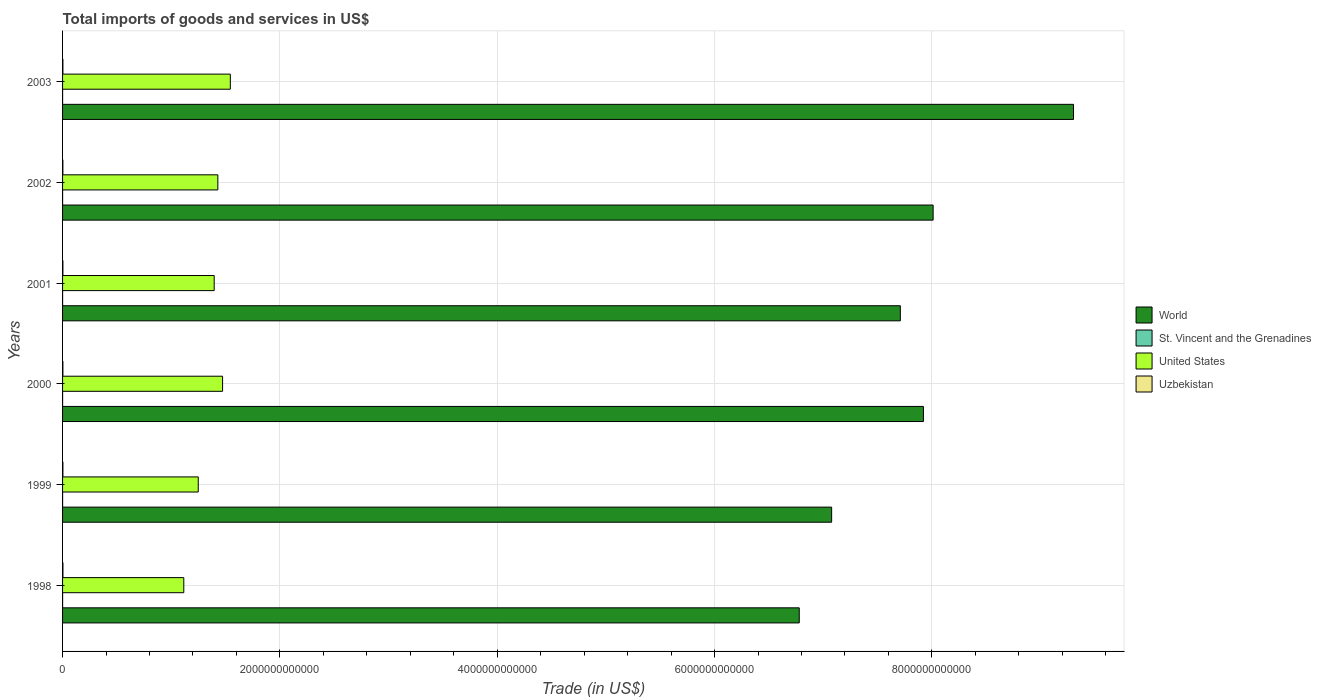How many groups of bars are there?
Your answer should be compact. 6. Are the number of bars per tick equal to the number of legend labels?
Your response must be concise. Yes. Are the number of bars on each tick of the Y-axis equal?
Provide a short and direct response. Yes. How many bars are there on the 5th tick from the bottom?
Offer a very short reply. 4. What is the total imports of goods and services in United States in 2000?
Make the answer very short. 1.47e+12. Across all years, what is the maximum total imports of goods and services in St. Vincent and the Grenadines?
Give a very brief answer. 2.49e+08. Across all years, what is the minimum total imports of goods and services in St. Vincent and the Grenadines?
Provide a succinct answer. 2.00e+08. In which year was the total imports of goods and services in Uzbekistan minimum?
Provide a short and direct response. 2002. What is the total total imports of goods and services in United States in the graph?
Provide a succinct answer. 8.21e+12. What is the difference between the total imports of goods and services in St. Vincent and the Grenadines in 2000 and that in 2002?
Offer a terse response. -1.43e+07. What is the difference between the total imports of goods and services in St. Vincent and the Grenadines in 2000 and the total imports of goods and services in World in 2001?
Your answer should be compact. -7.71e+12. What is the average total imports of goods and services in World per year?
Provide a short and direct response. 7.80e+12. In the year 2002, what is the difference between the total imports of goods and services in Uzbekistan and total imports of goods and services in World?
Give a very brief answer. -8.01e+12. What is the ratio of the total imports of goods and services in St. Vincent and the Grenadines in 1999 to that in 2001?
Offer a very short reply. 1.15. Is the total imports of goods and services in United States in 1998 less than that in 2001?
Offer a terse response. Yes. What is the difference between the highest and the second highest total imports of goods and services in St. Vincent and the Grenadines?
Offer a terse response. 7.62e+06. What is the difference between the highest and the lowest total imports of goods and services in United States?
Give a very brief answer. 4.28e+11. In how many years, is the total imports of goods and services in United States greater than the average total imports of goods and services in United States taken over all years?
Make the answer very short. 4. Is the sum of the total imports of goods and services in St. Vincent and the Grenadines in 1999 and 2003 greater than the maximum total imports of goods and services in United States across all years?
Your answer should be very brief. No. Is it the case that in every year, the sum of the total imports of goods and services in Uzbekistan and total imports of goods and services in World is greater than the sum of total imports of goods and services in United States and total imports of goods and services in St. Vincent and the Grenadines?
Provide a succinct answer. No. What does the 1st bar from the top in 2002 represents?
Your answer should be very brief. Uzbekistan. Is it the case that in every year, the sum of the total imports of goods and services in St. Vincent and the Grenadines and total imports of goods and services in Uzbekistan is greater than the total imports of goods and services in World?
Make the answer very short. No. How many years are there in the graph?
Provide a short and direct response. 6. What is the difference between two consecutive major ticks on the X-axis?
Offer a very short reply. 2.00e+12. What is the title of the graph?
Your response must be concise. Total imports of goods and services in US$. What is the label or title of the X-axis?
Ensure brevity in your answer.  Trade (in US$). What is the label or title of the Y-axis?
Provide a short and direct response. Years. What is the Trade (in US$) in World in 1998?
Keep it short and to the point. 6.78e+12. What is the Trade (in US$) of St. Vincent and the Grenadines in 1998?
Provide a short and direct response. 2.49e+08. What is the Trade (in US$) in United States in 1998?
Offer a very short reply. 1.12e+12. What is the Trade (in US$) in Uzbekistan in 1998?
Provide a succinct answer. 3.42e+09. What is the Trade (in US$) of World in 1999?
Your answer should be very brief. 7.08e+12. What is the Trade (in US$) in St. Vincent and the Grenadines in 1999?
Offer a very short reply. 2.40e+08. What is the Trade (in US$) in United States in 1999?
Give a very brief answer. 1.25e+12. What is the Trade (in US$) of Uzbekistan in 1999?
Your response must be concise. 3.14e+09. What is the Trade (in US$) in World in 2000?
Your response must be concise. 7.92e+12. What is the Trade (in US$) of St. Vincent and the Grenadines in 2000?
Your response must be concise. 2.00e+08. What is the Trade (in US$) in United States in 2000?
Your response must be concise. 1.47e+12. What is the Trade (in US$) in Uzbekistan in 2000?
Give a very brief answer. 2.96e+09. What is the Trade (in US$) of World in 2001?
Your response must be concise. 7.71e+12. What is the Trade (in US$) in St. Vincent and the Grenadines in 2001?
Provide a succinct answer. 2.09e+08. What is the Trade (in US$) in United States in 2001?
Provide a short and direct response. 1.40e+12. What is the Trade (in US$) of Uzbekistan in 2001?
Make the answer very short. 3.15e+09. What is the Trade (in US$) in World in 2002?
Make the answer very short. 8.01e+12. What is the Trade (in US$) of St. Vincent and the Grenadines in 2002?
Provide a short and direct response. 2.15e+08. What is the Trade (in US$) of United States in 2002?
Ensure brevity in your answer.  1.43e+12. What is the Trade (in US$) in Uzbekistan in 2002?
Your response must be concise. 2.84e+09. What is the Trade (in US$) in World in 2003?
Offer a very short reply. 9.30e+12. What is the Trade (in US$) in St. Vincent and the Grenadines in 2003?
Your answer should be very brief. 2.41e+08. What is the Trade (in US$) in United States in 2003?
Offer a terse response. 1.54e+12. What is the Trade (in US$) in Uzbekistan in 2003?
Give a very brief answer. 3.10e+09. Across all years, what is the maximum Trade (in US$) of World?
Keep it short and to the point. 9.30e+12. Across all years, what is the maximum Trade (in US$) of St. Vincent and the Grenadines?
Your answer should be very brief. 2.49e+08. Across all years, what is the maximum Trade (in US$) in United States?
Provide a short and direct response. 1.54e+12. Across all years, what is the maximum Trade (in US$) of Uzbekistan?
Your answer should be compact. 3.42e+09. Across all years, what is the minimum Trade (in US$) in World?
Keep it short and to the point. 6.78e+12. Across all years, what is the minimum Trade (in US$) of St. Vincent and the Grenadines?
Provide a succinct answer. 2.00e+08. Across all years, what is the minimum Trade (in US$) of United States?
Make the answer very short. 1.12e+12. Across all years, what is the minimum Trade (in US$) of Uzbekistan?
Ensure brevity in your answer.  2.84e+09. What is the total Trade (in US$) in World in the graph?
Ensure brevity in your answer.  4.68e+13. What is the total Trade (in US$) of St. Vincent and the Grenadines in the graph?
Make the answer very short. 1.36e+09. What is the total Trade (in US$) of United States in the graph?
Give a very brief answer. 8.21e+12. What is the total Trade (in US$) of Uzbekistan in the graph?
Offer a terse response. 1.86e+1. What is the difference between the Trade (in US$) in World in 1998 and that in 1999?
Keep it short and to the point. -2.98e+11. What is the difference between the Trade (in US$) of St. Vincent and the Grenadines in 1998 and that in 1999?
Keep it short and to the point. 9.04e+06. What is the difference between the Trade (in US$) in United States in 1998 and that in 1999?
Your answer should be compact. -1.33e+11. What is the difference between the Trade (in US$) of Uzbekistan in 1998 and that in 1999?
Offer a very short reply. 2.73e+08. What is the difference between the Trade (in US$) in World in 1998 and that in 2000?
Your answer should be very brief. -1.14e+12. What is the difference between the Trade (in US$) of St. Vincent and the Grenadines in 1998 and that in 2000?
Keep it short and to the point. 4.85e+07. What is the difference between the Trade (in US$) of United States in 1998 and that in 2000?
Provide a succinct answer. -3.57e+11. What is the difference between the Trade (in US$) of Uzbekistan in 1998 and that in 2000?
Your answer should be very brief. 4.55e+08. What is the difference between the Trade (in US$) of World in 1998 and that in 2001?
Your answer should be compact. -9.30e+11. What is the difference between the Trade (in US$) in St. Vincent and the Grenadines in 1998 and that in 2001?
Offer a very short reply. 3.96e+07. What is the difference between the Trade (in US$) of United States in 1998 and that in 2001?
Your answer should be compact. -2.80e+11. What is the difference between the Trade (in US$) of Uzbekistan in 1998 and that in 2001?
Offer a terse response. 2.65e+08. What is the difference between the Trade (in US$) in World in 1998 and that in 2002?
Make the answer very short. -1.23e+12. What is the difference between the Trade (in US$) in St. Vincent and the Grenadines in 1998 and that in 2002?
Provide a short and direct response. 3.42e+07. What is the difference between the Trade (in US$) of United States in 1998 and that in 2002?
Offer a terse response. -3.13e+11. What is the difference between the Trade (in US$) of Uzbekistan in 1998 and that in 2002?
Offer a terse response. 5.74e+08. What is the difference between the Trade (in US$) in World in 1998 and that in 2003?
Your answer should be very brief. -2.52e+12. What is the difference between the Trade (in US$) in St. Vincent and the Grenadines in 1998 and that in 2003?
Your response must be concise. 7.62e+06. What is the difference between the Trade (in US$) in United States in 1998 and that in 2003?
Ensure brevity in your answer.  -4.28e+11. What is the difference between the Trade (in US$) in Uzbekistan in 1998 and that in 2003?
Keep it short and to the point. 3.20e+08. What is the difference between the Trade (in US$) in World in 1999 and that in 2000?
Offer a terse response. -8.45e+11. What is the difference between the Trade (in US$) of St. Vincent and the Grenadines in 1999 and that in 2000?
Offer a very short reply. 3.95e+07. What is the difference between the Trade (in US$) of United States in 1999 and that in 2000?
Offer a very short reply. -2.24e+11. What is the difference between the Trade (in US$) of Uzbekistan in 1999 and that in 2000?
Your answer should be very brief. 1.82e+08. What is the difference between the Trade (in US$) in World in 1999 and that in 2001?
Your answer should be very brief. -6.32e+11. What is the difference between the Trade (in US$) of St. Vincent and the Grenadines in 1999 and that in 2001?
Keep it short and to the point. 3.05e+07. What is the difference between the Trade (in US$) of United States in 1999 and that in 2001?
Keep it short and to the point. -1.47e+11. What is the difference between the Trade (in US$) in Uzbekistan in 1999 and that in 2001?
Give a very brief answer. -8.00e+06. What is the difference between the Trade (in US$) in World in 1999 and that in 2002?
Keep it short and to the point. -9.34e+11. What is the difference between the Trade (in US$) in St. Vincent and the Grenadines in 1999 and that in 2002?
Your answer should be compact. 2.52e+07. What is the difference between the Trade (in US$) of United States in 1999 and that in 2002?
Your answer should be compact. -1.80e+11. What is the difference between the Trade (in US$) in Uzbekistan in 1999 and that in 2002?
Ensure brevity in your answer.  3.01e+08. What is the difference between the Trade (in US$) of World in 1999 and that in 2003?
Your answer should be very brief. -2.23e+12. What is the difference between the Trade (in US$) of St. Vincent and the Grenadines in 1999 and that in 2003?
Give a very brief answer. -1.42e+06. What is the difference between the Trade (in US$) in United States in 1999 and that in 2003?
Your response must be concise. -2.95e+11. What is the difference between the Trade (in US$) of Uzbekistan in 1999 and that in 2003?
Keep it short and to the point. 4.70e+07. What is the difference between the Trade (in US$) of World in 2000 and that in 2001?
Your response must be concise. 2.13e+11. What is the difference between the Trade (in US$) in St. Vincent and the Grenadines in 2000 and that in 2001?
Ensure brevity in your answer.  -8.99e+06. What is the difference between the Trade (in US$) of United States in 2000 and that in 2001?
Make the answer very short. 7.72e+1. What is the difference between the Trade (in US$) in Uzbekistan in 2000 and that in 2001?
Your answer should be very brief. -1.90e+08. What is the difference between the Trade (in US$) in World in 2000 and that in 2002?
Give a very brief answer. -8.91e+1. What is the difference between the Trade (in US$) of St. Vincent and the Grenadines in 2000 and that in 2002?
Your answer should be very brief. -1.43e+07. What is the difference between the Trade (in US$) of United States in 2000 and that in 2002?
Offer a terse response. 4.37e+1. What is the difference between the Trade (in US$) in Uzbekistan in 2000 and that in 2002?
Your answer should be very brief. 1.19e+08. What is the difference between the Trade (in US$) in World in 2000 and that in 2003?
Give a very brief answer. -1.38e+12. What is the difference between the Trade (in US$) of St. Vincent and the Grenadines in 2000 and that in 2003?
Make the answer very short. -4.09e+07. What is the difference between the Trade (in US$) in United States in 2000 and that in 2003?
Ensure brevity in your answer.  -7.13e+1. What is the difference between the Trade (in US$) in Uzbekistan in 2000 and that in 2003?
Give a very brief answer. -1.35e+08. What is the difference between the Trade (in US$) in World in 2001 and that in 2002?
Make the answer very short. -3.02e+11. What is the difference between the Trade (in US$) of St. Vincent and the Grenadines in 2001 and that in 2002?
Ensure brevity in your answer.  -5.36e+06. What is the difference between the Trade (in US$) of United States in 2001 and that in 2002?
Keep it short and to the point. -3.36e+1. What is the difference between the Trade (in US$) of Uzbekistan in 2001 and that in 2002?
Your answer should be very brief. 3.09e+08. What is the difference between the Trade (in US$) of World in 2001 and that in 2003?
Make the answer very short. -1.59e+12. What is the difference between the Trade (in US$) in St. Vincent and the Grenadines in 2001 and that in 2003?
Give a very brief answer. -3.19e+07. What is the difference between the Trade (in US$) in United States in 2001 and that in 2003?
Offer a terse response. -1.49e+11. What is the difference between the Trade (in US$) of Uzbekistan in 2001 and that in 2003?
Give a very brief answer. 5.50e+07. What is the difference between the Trade (in US$) of World in 2002 and that in 2003?
Provide a succinct answer. -1.29e+12. What is the difference between the Trade (in US$) of St. Vincent and the Grenadines in 2002 and that in 2003?
Offer a terse response. -2.66e+07. What is the difference between the Trade (in US$) of United States in 2002 and that in 2003?
Ensure brevity in your answer.  -1.15e+11. What is the difference between the Trade (in US$) of Uzbekistan in 2002 and that in 2003?
Give a very brief answer. -2.54e+08. What is the difference between the Trade (in US$) of World in 1998 and the Trade (in US$) of St. Vincent and the Grenadines in 1999?
Make the answer very short. 6.78e+12. What is the difference between the Trade (in US$) of World in 1998 and the Trade (in US$) of United States in 1999?
Provide a succinct answer. 5.53e+12. What is the difference between the Trade (in US$) of World in 1998 and the Trade (in US$) of Uzbekistan in 1999?
Keep it short and to the point. 6.78e+12. What is the difference between the Trade (in US$) in St. Vincent and the Grenadines in 1998 and the Trade (in US$) in United States in 1999?
Offer a very short reply. -1.25e+12. What is the difference between the Trade (in US$) in St. Vincent and the Grenadines in 1998 and the Trade (in US$) in Uzbekistan in 1999?
Provide a succinct answer. -2.89e+09. What is the difference between the Trade (in US$) of United States in 1998 and the Trade (in US$) of Uzbekistan in 1999?
Your response must be concise. 1.11e+12. What is the difference between the Trade (in US$) of World in 1998 and the Trade (in US$) of St. Vincent and the Grenadines in 2000?
Give a very brief answer. 6.78e+12. What is the difference between the Trade (in US$) of World in 1998 and the Trade (in US$) of United States in 2000?
Provide a succinct answer. 5.31e+12. What is the difference between the Trade (in US$) of World in 1998 and the Trade (in US$) of Uzbekistan in 2000?
Provide a short and direct response. 6.78e+12. What is the difference between the Trade (in US$) in St. Vincent and the Grenadines in 1998 and the Trade (in US$) in United States in 2000?
Provide a succinct answer. -1.47e+12. What is the difference between the Trade (in US$) of St. Vincent and the Grenadines in 1998 and the Trade (in US$) of Uzbekistan in 2000?
Provide a short and direct response. -2.71e+09. What is the difference between the Trade (in US$) of United States in 1998 and the Trade (in US$) of Uzbekistan in 2000?
Provide a short and direct response. 1.11e+12. What is the difference between the Trade (in US$) of World in 1998 and the Trade (in US$) of St. Vincent and the Grenadines in 2001?
Make the answer very short. 6.78e+12. What is the difference between the Trade (in US$) in World in 1998 and the Trade (in US$) in United States in 2001?
Offer a very short reply. 5.38e+12. What is the difference between the Trade (in US$) in World in 1998 and the Trade (in US$) in Uzbekistan in 2001?
Your answer should be compact. 6.78e+12. What is the difference between the Trade (in US$) of St. Vincent and the Grenadines in 1998 and the Trade (in US$) of United States in 2001?
Give a very brief answer. -1.40e+12. What is the difference between the Trade (in US$) of St. Vincent and the Grenadines in 1998 and the Trade (in US$) of Uzbekistan in 2001?
Make the answer very short. -2.90e+09. What is the difference between the Trade (in US$) in United States in 1998 and the Trade (in US$) in Uzbekistan in 2001?
Make the answer very short. 1.11e+12. What is the difference between the Trade (in US$) in World in 1998 and the Trade (in US$) in St. Vincent and the Grenadines in 2002?
Provide a succinct answer. 6.78e+12. What is the difference between the Trade (in US$) in World in 1998 and the Trade (in US$) in United States in 2002?
Provide a short and direct response. 5.35e+12. What is the difference between the Trade (in US$) in World in 1998 and the Trade (in US$) in Uzbekistan in 2002?
Your answer should be very brief. 6.78e+12. What is the difference between the Trade (in US$) of St. Vincent and the Grenadines in 1998 and the Trade (in US$) of United States in 2002?
Keep it short and to the point. -1.43e+12. What is the difference between the Trade (in US$) of St. Vincent and the Grenadines in 1998 and the Trade (in US$) of Uzbekistan in 2002?
Provide a succinct answer. -2.59e+09. What is the difference between the Trade (in US$) in United States in 1998 and the Trade (in US$) in Uzbekistan in 2002?
Provide a succinct answer. 1.11e+12. What is the difference between the Trade (in US$) in World in 1998 and the Trade (in US$) in St. Vincent and the Grenadines in 2003?
Offer a terse response. 6.78e+12. What is the difference between the Trade (in US$) in World in 1998 and the Trade (in US$) in United States in 2003?
Ensure brevity in your answer.  5.24e+12. What is the difference between the Trade (in US$) in World in 1998 and the Trade (in US$) in Uzbekistan in 2003?
Your response must be concise. 6.78e+12. What is the difference between the Trade (in US$) of St. Vincent and the Grenadines in 1998 and the Trade (in US$) of United States in 2003?
Make the answer very short. -1.54e+12. What is the difference between the Trade (in US$) of St. Vincent and the Grenadines in 1998 and the Trade (in US$) of Uzbekistan in 2003?
Make the answer very short. -2.85e+09. What is the difference between the Trade (in US$) in United States in 1998 and the Trade (in US$) in Uzbekistan in 2003?
Ensure brevity in your answer.  1.11e+12. What is the difference between the Trade (in US$) of World in 1999 and the Trade (in US$) of St. Vincent and the Grenadines in 2000?
Your answer should be compact. 7.08e+12. What is the difference between the Trade (in US$) in World in 1999 and the Trade (in US$) in United States in 2000?
Keep it short and to the point. 5.61e+12. What is the difference between the Trade (in US$) of World in 1999 and the Trade (in US$) of Uzbekistan in 2000?
Offer a very short reply. 7.07e+12. What is the difference between the Trade (in US$) of St. Vincent and the Grenadines in 1999 and the Trade (in US$) of United States in 2000?
Offer a terse response. -1.47e+12. What is the difference between the Trade (in US$) in St. Vincent and the Grenadines in 1999 and the Trade (in US$) in Uzbekistan in 2000?
Give a very brief answer. -2.72e+09. What is the difference between the Trade (in US$) of United States in 1999 and the Trade (in US$) of Uzbekistan in 2000?
Provide a succinct answer. 1.25e+12. What is the difference between the Trade (in US$) in World in 1999 and the Trade (in US$) in St. Vincent and the Grenadines in 2001?
Offer a terse response. 7.08e+12. What is the difference between the Trade (in US$) in World in 1999 and the Trade (in US$) in United States in 2001?
Provide a succinct answer. 5.68e+12. What is the difference between the Trade (in US$) in World in 1999 and the Trade (in US$) in Uzbekistan in 2001?
Offer a very short reply. 7.07e+12. What is the difference between the Trade (in US$) of St. Vincent and the Grenadines in 1999 and the Trade (in US$) of United States in 2001?
Give a very brief answer. -1.40e+12. What is the difference between the Trade (in US$) of St. Vincent and the Grenadines in 1999 and the Trade (in US$) of Uzbekistan in 2001?
Your answer should be compact. -2.91e+09. What is the difference between the Trade (in US$) in United States in 1999 and the Trade (in US$) in Uzbekistan in 2001?
Ensure brevity in your answer.  1.25e+12. What is the difference between the Trade (in US$) in World in 1999 and the Trade (in US$) in St. Vincent and the Grenadines in 2002?
Offer a terse response. 7.08e+12. What is the difference between the Trade (in US$) in World in 1999 and the Trade (in US$) in United States in 2002?
Provide a succinct answer. 5.65e+12. What is the difference between the Trade (in US$) of World in 1999 and the Trade (in US$) of Uzbekistan in 2002?
Provide a succinct answer. 7.07e+12. What is the difference between the Trade (in US$) in St. Vincent and the Grenadines in 1999 and the Trade (in US$) in United States in 2002?
Provide a short and direct response. -1.43e+12. What is the difference between the Trade (in US$) in St. Vincent and the Grenadines in 1999 and the Trade (in US$) in Uzbekistan in 2002?
Provide a succinct answer. -2.60e+09. What is the difference between the Trade (in US$) in United States in 1999 and the Trade (in US$) in Uzbekistan in 2002?
Keep it short and to the point. 1.25e+12. What is the difference between the Trade (in US$) of World in 1999 and the Trade (in US$) of St. Vincent and the Grenadines in 2003?
Your response must be concise. 7.08e+12. What is the difference between the Trade (in US$) in World in 1999 and the Trade (in US$) in United States in 2003?
Offer a terse response. 5.53e+12. What is the difference between the Trade (in US$) in World in 1999 and the Trade (in US$) in Uzbekistan in 2003?
Your response must be concise. 7.07e+12. What is the difference between the Trade (in US$) of St. Vincent and the Grenadines in 1999 and the Trade (in US$) of United States in 2003?
Provide a short and direct response. -1.54e+12. What is the difference between the Trade (in US$) of St. Vincent and the Grenadines in 1999 and the Trade (in US$) of Uzbekistan in 2003?
Ensure brevity in your answer.  -2.86e+09. What is the difference between the Trade (in US$) of United States in 1999 and the Trade (in US$) of Uzbekistan in 2003?
Your answer should be compact. 1.25e+12. What is the difference between the Trade (in US$) of World in 2000 and the Trade (in US$) of St. Vincent and the Grenadines in 2001?
Give a very brief answer. 7.92e+12. What is the difference between the Trade (in US$) in World in 2000 and the Trade (in US$) in United States in 2001?
Make the answer very short. 6.53e+12. What is the difference between the Trade (in US$) of World in 2000 and the Trade (in US$) of Uzbekistan in 2001?
Your answer should be compact. 7.92e+12. What is the difference between the Trade (in US$) of St. Vincent and the Grenadines in 2000 and the Trade (in US$) of United States in 2001?
Your answer should be compact. -1.40e+12. What is the difference between the Trade (in US$) of St. Vincent and the Grenadines in 2000 and the Trade (in US$) of Uzbekistan in 2001?
Keep it short and to the point. -2.95e+09. What is the difference between the Trade (in US$) of United States in 2000 and the Trade (in US$) of Uzbekistan in 2001?
Give a very brief answer. 1.47e+12. What is the difference between the Trade (in US$) of World in 2000 and the Trade (in US$) of St. Vincent and the Grenadines in 2002?
Offer a very short reply. 7.92e+12. What is the difference between the Trade (in US$) in World in 2000 and the Trade (in US$) in United States in 2002?
Provide a short and direct response. 6.49e+12. What is the difference between the Trade (in US$) in World in 2000 and the Trade (in US$) in Uzbekistan in 2002?
Provide a short and direct response. 7.92e+12. What is the difference between the Trade (in US$) in St. Vincent and the Grenadines in 2000 and the Trade (in US$) in United States in 2002?
Keep it short and to the point. -1.43e+12. What is the difference between the Trade (in US$) in St. Vincent and the Grenadines in 2000 and the Trade (in US$) in Uzbekistan in 2002?
Give a very brief answer. -2.64e+09. What is the difference between the Trade (in US$) of United States in 2000 and the Trade (in US$) of Uzbekistan in 2002?
Your response must be concise. 1.47e+12. What is the difference between the Trade (in US$) of World in 2000 and the Trade (in US$) of St. Vincent and the Grenadines in 2003?
Your answer should be very brief. 7.92e+12. What is the difference between the Trade (in US$) in World in 2000 and the Trade (in US$) in United States in 2003?
Make the answer very short. 6.38e+12. What is the difference between the Trade (in US$) in World in 2000 and the Trade (in US$) in Uzbekistan in 2003?
Provide a short and direct response. 7.92e+12. What is the difference between the Trade (in US$) in St. Vincent and the Grenadines in 2000 and the Trade (in US$) in United States in 2003?
Offer a very short reply. -1.54e+12. What is the difference between the Trade (in US$) of St. Vincent and the Grenadines in 2000 and the Trade (in US$) of Uzbekistan in 2003?
Ensure brevity in your answer.  -2.90e+09. What is the difference between the Trade (in US$) in United States in 2000 and the Trade (in US$) in Uzbekistan in 2003?
Your response must be concise. 1.47e+12. What is the difference between the Trade (in US$) in World in 2001 and the Trade (in US$) in St. Vincent and the Grenadines in 2002?
Keep it short and to the point. 7.71e+12. What is the difference between the Trade (in US$) of World in 2001 and the Trade (in US$) of United States in 2002?
Provide a succinct answer. 6.28e+12. What is the difference between the Trade (in US$) of World in 2001 and the Trade (in US$) of Uzbekistan in 2002?
Ensure brevity in your answer.  7.71e+12. What is the difference between the Trade (in US$) in St. Vincent and the Grenadines in 2001 and the Trade (in US$) in United States in 2002?
Keep it short and to the point. -1.43e+12. What is the difference between the Trade (in US$) in St. Vincent and the Grenadines in 2001 and the Trade (in US$) in Uzbekistan in 2002?
Your answer should be very brief. -2.63e+09. What is the difference between the Trade (in US$) in United States in 2001 and the Trade (in US$) in Uzbekistan in 2002?
Keep it short and to the point. 1.39e+12. What is the difference between the Trade (in US$) of World in 2001 and the Trade (in US$) of St. Vincent and the Grenadines in 2003?
Offer a terse response. 7.71e+12. What is the difference between the Trade (in US$) of World in 2001 and the Trade (in US$) of United States in 2003?
Offer a terse response. 6.17e+12. What is the difference between the Trade (in US$) of World in 2001 and the Trade (in US$) of Uzbekistan in 2003?
Give a very brief answer. 7.71e+12. What is the difference between the Trade (in US$) of St. Vincent and the Grenadines in 2001 and the Trade (in US$) of United States in 2003?
Provide a short and direct response. -1.54e+12. What is the difference between the Trade (in US$) of St. Vincent and the Grenadines in 2001 and the Trade (in US$) of Uzbekistan in 2003?
Offer a very short reply. -2.89e+09. What is the difference between the Trade (in US$) in United States in 2001 and the Trade (in US$) in Uzbekistan in 2003?
Offer a terse response. 1.39e+12. What is the difference between the Trade (in US$) of World in 2002 and the Trade (in US$) of St. Vincent and the Grenadines in 2003?
Give a very brief answer. 8.01e+12. What is the difference between the Trade (in US$) of World in 2002 and the Trade (in US$) of United States in 2003?
Make the answer very short. 6.47e+12. What is the difference between the Trade (in US$) of World in 2002 and the Trade (in US$) of Uzbekistan in 2003?
Make the answer very short. 8.01e+12. What is the difference between the Trade (in US$) in St. Vincent and the Grenadines in 2002 and the Trade (in US$) in United States in 2003?
Keep it short and to the point. -1.54e+12. What is the difference between the Trade (in US$) in St. Vincent and the Grenadines in 2002 and the Trade (in US$) in Uzbekistan in 2003?
Your response must be concise. -2.88e+09. What is the difference between the Trade (in US$) of United States in 2002 and the Trade (in US$) of Uzbekistan in 2003?
Provide a short and direct response. 1.43e+12. What is the average Trade (in US$) of World per year?
Provide a short and direct response. 7.80e+12. What is the average Trade (in US$) in St. Vincent and the Grenadines per year?
Your answer should be very brief. 2.26e+08. What is the average Trade (in US$) of United States per year?
Make the answer very short. 1.37e+12. What is the average Trade (in US$) in Uzbekistan per year?
Offer a very short reply. 3.10e+09. In the year 1998, what is the difference between the Trade (in US$) in World and Trade (in US$) in St. Vincent and the Grenadines?
Give a very brief answer. 6.78e+12. In the year 1998, what is the difference between the Trade (in US$) of World and Trade (in US$) of United States?
Offer a terse response. 5.66e+12. In the year 1998, what is the difference between the Trade (in US$) in World and Trade (in US$) in Uzbekistan?
Offer a terse response. 6.78e+12. In the year 1998, what is the difference between the Trade (in US$) in St. Vincent and the Grenadines and Trade (in US$) in United States?
Your answer should be compact. -1.12e+12. In the year 1998, what is the difference between the Trade (in US$) of St. Vincent and the Grenadines and Trade (in US$) of Uzbekistan?
Your response must be concise. -3.17e+09. In the year 1998, what is the difference between the Trade (in US$) of United States and Trade (in US$) of Uzbekistan?
Your response must be concise. 1.11e+12. In the year 1999, what is the difference between the Trade (in US$) in World and Trade (in US$) in St. Vincent and the Grenadines?
Offer a terse response. 7.08e+12. In the year 1999, what is the difference between the Trade (in US$) of World and Trade (in US$) of United States?
Your answer should be compact. 5.83e+12. In the year 1999, what is the difference between the Trade (in US$) in World and Trade (in US$) in Uzbekistan?
Provide a succinct answer. 7.07e+12. In the year 1999, what is the difference between the Trade (in US$) in St. Vincent and the Grenadines and Trade (in US$) in United States?
Offer a terse response. -1.25e+12. In the year 1999, what is the difference between the Trade (in US$) of St. Vincent and the Grenadines and Trade (in US$) of Uzbekistan?
Keep it short and to the point. -2.90e+09. In the year 1999, what is the difference between the Trade (in US$) of United States and Trade (in US$) of Uzbekistan?
Offer a very short reply. 1.25e+12. In the year 2000, what is the difference between the Trade (in US$) in World and Trade (in US$) in St. Vincent and the Grenadines?
Your answer should be very brief. 7.92e+12. In the year 2000, what is the difference between the Trade (in US$) in World and Trade (in US$) in United States?
Offer a very short reply. 6.45e+12. In the year 2000, what is the difference between the Trade (in US$) of World and Trade (in US$) of Uzbekistan?
Give a very brief answer. 7.92e+12. In the year 2000, what is the difference between the Trade (in US$) of St. Vincent and the Grenadines and Trade (in US$) of United States?
Provide a succinct answer. -1.47e+12. In the year 2000, what is the difference between the Trade (in US$) in St. Vincent and the Grenadines and Trade (in US$) in Uzbekistan?
Give a very brief answer. -2.76e+09. In the year 2000, what is the difference between the Trade (in US$) of United States and Trade (in US$) of Uzbekistan?
Give a very brief answer. 1.47e+12. In the year 2001, what is the difference between the Trade (in US$) in World and Trade (in US$) in St. Vincent and the Grenadines?
Your answer should be very brief. 7.71e+12. In the year 2001, what is the difference between the Trade (in US$) in World and Trade (in US$) in United States?
Keep it short and to the point. 6.31e+12. In the year 2001, what is the difference between the Trade (in US$) of World and Trade (in US$) of Uzbekistan?
Keep it short and to the point. 7.71e+12. In the year 2001, what is the difference between the Trade (in US$) of St. Vincent and the Grenadines and Trade (in US$) of United States?
Give a very brief answer. -1.40e+12. In the year 2001, what is the difference between the Trade (in US$) of St. Vincent and the Grenadines and Trade (in US$) of Uzbekistan?
Provide a short and direct response. -2.94e+09. In the year 2001, what is the difference between the Trade (in US$) in United States and Trade (in US$) in Uzbekistan?
Your answer should be compact. 1.39e+12. In the year 2002, what is the difference between the Trade (in US$) of World and Trade (in US$) of St. Vincent and the Grenadines?
Your answer should be compact. 8.01e+12. In the year 2002, what is the difference between the Trade (in US$) of World and Trade (in US$) of United States?
Your response must be concise. 6.58e+12. In the year 2002, what is the difference between the Trade (in US$) of World and Trade (in US$) of Uzbekistan?
Provide a short and direct response. 8.01e+12. In the year 2002, what is the difference between the Trade (in US$) of St. Vincent and the Grenadines and Trade (in US$) of United States?
Your answer should be very brief. -1.43e+12. In the year 2002, what is the difference between the Trade (in US$) in St. Vincent and the Grenadines and Trade (in US$) in Uzbekistan?
Provide a short and direct response. -2.63e+09. In the year 2002, what is the difference between the Trade (in US$) of United States and Trade (in US$) of Uzbekistan?
Offer a terse response. 1.43e+12. In the year 2003, what is the difference between the Trade (in US$) in World and Trade (in US$) in St. Vincent and the Grenadines?
Offer a very short reply. 9.30e+12. In the year 2003, what is the difference between the Trade (in US$) in World and Trade (in US$) in United States?
Make the answer very short. 7.76e+12. In the year 2003, what is the difference between the Trade (in US$) of World and Trade (in US$) of Uzbekistan?
Ensure brevity in your answer.  9.30e+12. In the year 2003, what is the difference between the Trade (in US$) of St. Vincent and the Grenadines and Trade (in US$) of United States?
Ensure brevity in your answer.  -1.54e+12. In the year 2003, what is the difference between the Trade (in US$) in St. Vincent and the Grenadines and Trade (in US$) in Uzbekistan?
Provide a succinct answer. -2.86e+09. In the year 2003, what is the difference between the Trade (in US$) of United States and Trade (in US$) of Uzbekistan?
Provide a short and direct response. 1.54e+12. What is the ratio of the Trade (in US$) of World in 1998 to that in 1999?
Your answer should be compact. 0.96. What is the ratio of the Trade (in US$) of St. Vincent and the Grenadines in 1998 to that in 1999?
Your answer should be compact. 1.04. What is the ratio of the Trade (in US$) in United States in 1998 to that in 1999?
Keep it short and to the point. 0.89. What is the ratio of the Trade (in US$) in Uzbekistan in 1998 to that in 1999?
Your answer should be very brief. 1.09. What is the ratio of the Trade (in US$) in World in 1998 to that in 2000?
Give a very brief answer. 0.86. What is the ratio of the Trade (in US$) of St. Vincent and the Grenadines in 1998 to that in 2000?
Keep it short and to the point. 1.24. What is the ratio of the Trade (in US$) of United States in 1998 to that in 2000?
Make the answer very short. 0.76. What is the ratio of the Trade (in US$) of Uzbekistan in 1998 to that in 2000?
Ensure brevity in your answer.  1.15. What is the ratio of the Trade (in US$) of World in 1998 to that in 2001?
Offer a terse response. 0.88. What is the ratio of the Trade (in US$) of St. Vincent and the Grenadines in 1998 to that in 2001?
Provide a succinct answer. 1.19. What is the ratio of the Trade (in US$) of United States in 1998 to that in 2001?
Provide a short and direct response. 0.8. What is the ratio of the Trade (in US$) of Uzbekistan in 1998 to that in 2001?
Provide a short and direct response. 1.08. What is the ratio of the Trade (in US$) of World in 1998 to that in 2002?
Offer a terse response. 0.85. What is the ratio of the Trade (in US$) of St. Vincent and the Grenadines in 1998 to that in 2002?
Make the answer very short. 1.16. What is the ratio of the Trade (in US$) of United States in 1998 to that in 2002?
Provide a short and direct response. 0.78. What is the ratio of the Trade (in US$) in Uzbekistan in 1998 to that in 2002?
Your answer should be very brief. 1.2. What is the ratio of the Trade (in US$) in World in 1998 to that in 2003?
Provide a short and direct response. 0.73. What is the ratio of the Trade (in US$) in St. Vincent and the Grenadines in 1998 to that in 2003?
Your response must be concise. 1.03. What is the ratio of the Trade (in US$) of United States in 1998 to that in 2003?
Your response must be concise. 0.72. What is the ratio of the Trade (in US$) of Uzbekistan in 1998 to that in 2003?
Your response must be concise. 1.1. What is the ratio of the Trade (in US$) in World in 1999 to that in 2000?
Make the answer very short. 0.89. What is the ratio of the Trade (in US$) in St. Vincent and the Grenadines in 1999 to that in 2000?
Your answer should be very brief. 1.2. What is the ratio of the Trade (in US$) of United States in 1999 to that in 2000?
Your response must be concise. 0.85. What is the ratio of the Trade (in US$) of Uzbekistan in 1999 to that in 2000?
Provide a succinct answer. 1.06. What is the ratio of the Trade (in US$) in World in 1999 to that in 2001?
Provide a succinct answer. 0.92. What is the ratio of the Trade (in US$) of St. Vincent and the Grenadines in 1999 to that in 2001?
Your answer should be very brief. 1.15. What is the ratio of the Trade (in US$) in United States in 1999 to that in 2001?
Your response must be concise. 0.89. What is the ratio of the Trade (in US$) in World in 1999 to that in 2002?
Ensure brevity in your answer.  0.88. What is the ratio of the Trade (in US$) in St. Vincent and the Grenadines in 1999 to that in 2002?
Provide a succinct answer. 1.12. What is the ratio of the Trade (in US$) in United States in 1999 to that in 2002?
Ensure brevity in your answer.  0.87. What is the ratio of the Trade (in US$) of Uzbekistan in 1999 to that in 2002?
Ensure brevity in your answer.  1.11. What is the ratio of the Trade (in US$) of World in 1999 to that in 2003?
Keep it short and to the point. 0.76. What is the ratio of the Trade (in US$) in St. Vincent and the Grenadines in 1999 to that in 2003?
Make the answer very short. 0.99. What is the ratio of the Trade (in US$) in United States in 1999 to that in 2003?
Provide a short and direct response. 0.81. What is the ratio of the Trade (in US$) of Uzbekistan in 1999 to that in 2003?
Your answer should be compact. 1.02. What is the ratio of the Trade (in US$) of World in 2000 to that in 2001?
Provide a short and direct response. 1.03. What is the ratio of the Trade (in US$) of St. Vincent and the Grenadines in 2000 to that in 2001?
Give a very brief answer. 0.96. What is the ratio of the Trade (in US$) in United States in 2000 to that in 2001?
Keep it short and to the point. 1.06. What is the ratio of the Trade (in US$) in Uzbekistan in 2000 to that in 2001?
Give a very brief answer. 0.94. What is the ratio of the Trade (in US$) in World in 2000 to that in 2002?
Offer a very short reply. 0.99. What is the ratio of the Trade (in US$) in St. Vincent and the Grenadines in 2000 to that in 2002?
Offer a terse response. 0.93. What is the ratio of the Trade (in US$) of United States in 2000 to that in 2002?
Your answer should be compact. 1.03. What is the ratio of the Trade (in US$) in Uzbekistan in 2000 to that in 2002?
Your response must be concise. 1.04. What is the ratio of the Trade (in US$) in World in 2000 to that in 2003?
Your answer should be very brief. 0.85. What is the ratio of the Trade (in US$) in St. Vincent and the Grenadines in 2000 to that in 2003?
Provide a succinct answer. 0.83. What is the ratio of the Trade (in US$) in United States in 2000 to that in 2003?
Provide a succinct answer. 0.95. What is the ratio of the Trade (in US$) of Uzbekistan in 2000 to that in 2003?
Make the answer very short. 0.96. What is the ratio of the Trade (in US$) of World in 2001 to that in 2002?
Provide a succinct answer. 0.96. What is the ratio of the Trade (in US$) of United States in 2001 to that in 2002?
Your answer should be compact. 0.98. What is the ratio of the Trade (in US$) in Uzbekistan in 2001 to that in 2002?
Make the answer very short. 1.11. What is the ratio of the Trade (in US$) in World in 2001 to that in 2003?
Provide a short and direct response. 0.83. What is the ratio of the Trade (in US$) of St. Vincent and the Grenadines in 2001 to that in 2003?
Your response must be concise. 0.87. What is the ratio of the Trade (in US$) of United States in 2001 to that in 2003?
Give a very brief answer. 0.9. What is the ratio of the Trade (in US$) in Uzbekistan in 2001 to that in 2003?
Provide a succinct answer. 1.02. What is the ratio of the Trade (in US$) in World in 2002 to that in 2003?
Your response must be concise. 0.86. What is the ratio of the Trade (in US$) in St. Vincent and the Grenadines in 2002 to that in 2003?
Offer a very short reply. 0.89. What is the ratio of the Trade (in US$) in United States in 2002 to that in 2003?
Offer a very short reply. 0.93. What is the ratio of the Trade (in US$) of Uzbekistan in 2002 to that in 2003?
Give a very brief answer. 0.92. What is the difference between the highest and the second highest Trade (in US$) of World?
Ensure brevity in your answer.  1.29e+12. What is the difference between the highest and the second highest Trade (in US$) in St. Vincent and the Grenadines?
Offer a very short reply. 7.62e+06. What is the difference between the highest and the second highest Trade (in US$) in United States?
Make the answer very short. 7.13e+1. What is the difference between the highest and the second highest Trade (in US$) in Uzbekistan?
Provide a short and direct response. 2.65e+08. What is the difference between the highest and the lowest Trade (in US$) of World?
Offer a terse response. 2.52e+12. What is the difference between the highest and the lowest Trade (in US$) of St. Vincent and the Grenadines?
Your answer should be compact. 4.85e+07. What is the difference between the highest and the lowest Trade (in US$) of United States?
Make the answer very short. 4.28e+11. What is the difference between the highest and the lowest Trade (in US$) of Uzbekistan?
Keep it short and to the point. 5.74e+08. 